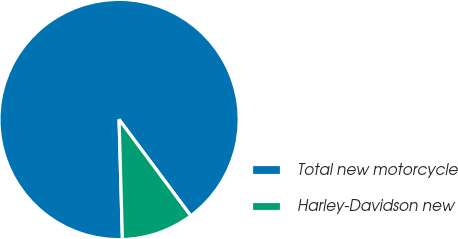Convert chart to OTSL. <chart><loc_0><loc_0><loc_500><loc_500><pie_chart><fcel>Total new motorcycle<fcel>Harley-Davidson new<nl><fcel>90.26%<fcel>9.74%<nl></chart> 